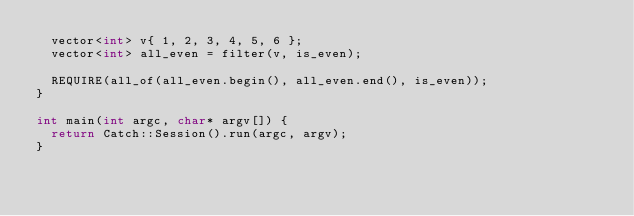<code> <loc_0><loc_0><loc_500><loc_500><_C++_>	vector<int> v{ 1, 2, 3, 4, 5, 6 };
	vector<int> all_even = filter(v, is_even);

	REQUIRE(all_of(all_even.begin(), all_even.end(), is_even));
}

int main(int argc, char* argv[]) {
	return Catch::Session().run(argc, argv);
}</code> 